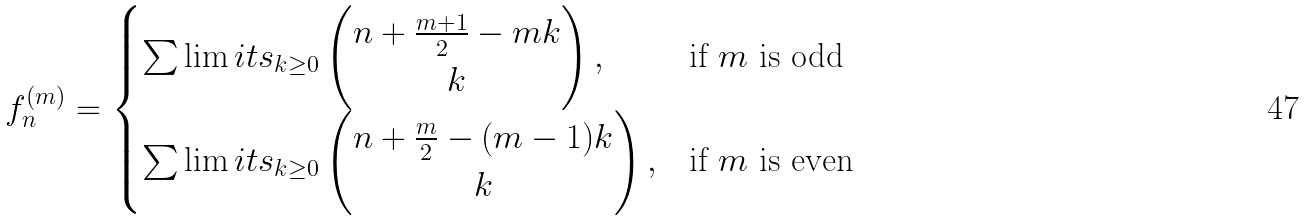<formula> <loc_0><loc_0><loc_500><loc_500>f ^ { ( m ) } _ { n } = \begin{cases} \sum \lim i t s _ { k \geq 0 } \begin{pmatrix} n + \frac { m + 1 } { 2 } - m k \\ k \end{pmatrix} , & \text {if $m$ is odd} \\ \sum \lim i t s _ { k \geq 0 } \begin{pmatrix} n + \frac { m } { 2 } - ( m - 1 ) k \\ k \end{pmatrix} , & \text {if $m$ is even} \end{cases}</formula> 